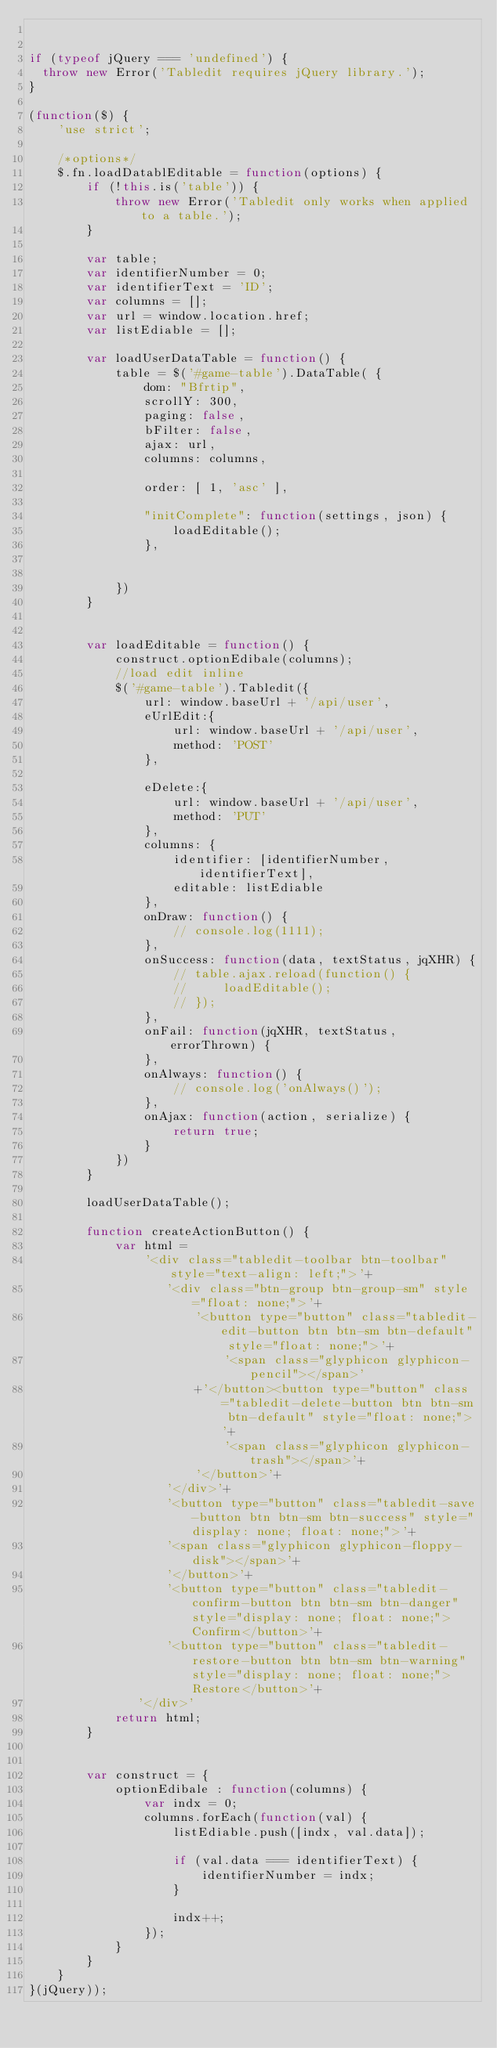<code> <loc_0><loc_0><loc_500><loc_500><_JavaScript_>

if (typeof jQuery === 'undefined') {
  throw new Error('Tabledit requires jQuery library.');
}

(function($) {
	'use strict';

	/*options*/
	$.fn.loadDatablEditable = function(options) {
		if (!this.is('table')) {
			throw new Error('Tabledit only works when applied to a table.');
		}

		var table;
		var identifierNumber = 0;
		var identifierText = 'ID';
		var columns = [];
		var url = window.location.href;
		var listEdiable = [];

	    var loadUserDataTable = function() {
	        table = $('#game-table').DataTable( {
	            dom: "Bfrtip",
	            scrollY: 300,
	            paging: false,
	            bFilter: false,
	            ajax: url,
	            columns: columns,
	            
	            order: [ 1, 'asc' ],

	            "initComplete": function(settings, json) {
	                loadEditable();
	            },

	            
	        })
	    }
	    

	    var loadEditable = function() {
	    	construct.optionEdibale(columns);
	        //load edit inline
	        $('#game-table').Tabledit({
	            url: window.baseUrl + '/api/user',
	            eUrlEdit:{
	                url: window.baseUrl + '/api/user',
	                method: 'POST'
	            },

	            eDelete:{
	                url: window.baseUrl + '/api/user',
	                method: 'PUT'
	            },
	            columns: {
	                identifier: [identifierNumber, identifierText],
	                editable: listEdiable
	            },
	            onDraw: function() {
	                // console.log(1111);
	            },
	            onSuccess: function(data, textStatus, jqXHR) {
	                // table.ajax.reload(function() {
	                //     loadEditable();
	                // });
	            },
	            onFail: function(jqXHR, textStatus, errorThrown) {
	            },
	            onAlways: function() {
	                // console.log('onAlways()');
	            },
	            onAjax: function(action, serialize) {
	                return true;
	            }
	        })
	    }

	    loadUserDataTable();

	    function createActionButton() {
	        var html =
	            '<div class="tabledit-toolbar btn-toolbar" style="text-align: left;">'+
	               '<div class="btn-group btn-group-sm" style="float: none;">'+
	                   '<button type="button" class="tabledit-edit-button btn btn-sm btn-default" style="float: none;">'+
	                       '<span class="glyphicon glyphicon-pencil"></span>'
	                   +'</button><button type="button" class="tabledit-delete-button btn btn-sm btn-default" style="float: none;">'+
	                       '<span class="glyphicon glyphicon-trash"></span>'+
	                   '</button>'+
	               '</div>'+
	               '<button type="button" class="tabledit-save-button btn btn-sm btn-success" style="display: none; float: none;">'+
	               '<span class="glyphicon glyphicon-floppy-disk"></span>'+
	               '</button>'+
	               '<button type="button" class="tabledit-confirm-button btn btn-sm btn-danger" style="display: none; float: none;">Confirm</button>'+
	               '<button type="button" class="tabledit-restore-button btn btn-sm btn-warning" style="display: none; float: none;">Restore</button>'+
	           '</div>'
	        return html;
	    }


	    var construct = {
	    	optionEdibale : function(columns) {
	    		var indx = 0;
	    		columns.forEach(function(val) {
	    			listEdiable.push([indx, val.data]);

	    			if (val.data === identifierText) {
	    				identifierNumber = indx;
	    			}

	    			indx++;
	    		});
	    	}
	    }
	}
}(jQuery));
</code> 